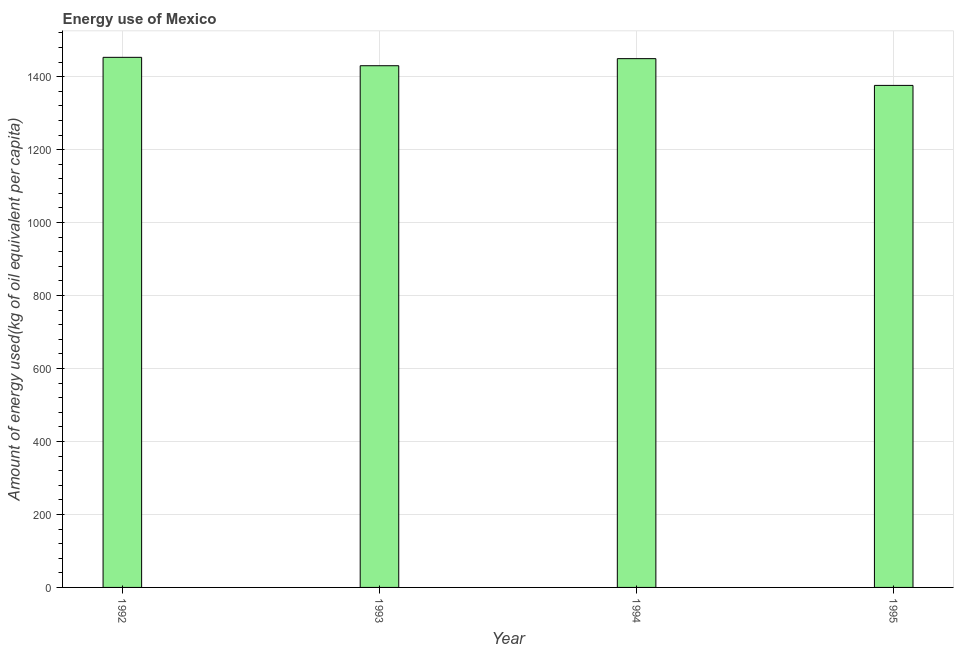What is the title of the graph?
Make the answer very short. Energy use of Mexico. What is the label or title of the X-axis?
Make the answer very short. Year. What is the label or title of the Y-axis?
Provide a short and direct response. Amount of energy used(kg of oil equivalent per capita). What is the amount of energy used in 1995?
Make the answer very short. 1376.02. Across all years, what is the maximum amount of energy used?
Provide a short and direct response. 1452.97. Across all years, what is the minimum amount of energy used?
Your response must be concise. 1376.02. In which year was the amount of energy used maximum?
Your answer should be compact. 1992. In which year was the amount of energy used minimum?
Your response must be concise. 1995. What is the sum of the amount of energy used?
Provide a succinct answer. 5708.33. What is the difference between the amount of energy used in 1993 and 1995?
Your answer should be very brief. 53.95. What is the average amount of energy used per year?
Your response must be concise. 1427.08. What is the median amount of energy used?
Offer a terse response. 1439.67. What is the ratio of the amount of energy used in 1992 to that in 1995?
Your response must be concise. 1.06. Is the difference between the amount of energy used in 1993 and 1994 greater than the difference between any two years?
Your response must be concise. No. What is the difference between the highest and the second highest amount of energy used?
Ensure brevity in your answer.  3.61. What is the difference between the highest and the lowest amount of energy used?
Offer a terse response. 76.95. In how many years, is the amount of energy used greater than the average amount of energy used taken over all years?
Provide a succinct answer. 3. How many bars are there?
Make the answer very short. 4. Are all the bars in the graph horizontal?
Your answer should be compact. No. How many years are there in the graph?
Offer a very short reply. 4. What is the difference between two consecutive major ticks on the Y-axis?
Provide a succinct answer. 200. What is the Amount of energy used(kg of oil equivalent per capita) of 1992?
Give a very brief answer. 1452.97. What is the Amount of energy used(kg of oil equivalent per capita) in 1993?
Ensure brevity in your answer.  1429.97. What is the Amount of energy used(kg of oil equivalent per capita) in 1994?
Keep it short and to the point. 1449.36. What is the Amount of energy used(kg of oil equivalent per capita) of 1995?
Your answer should be very brief. 1376.02. What is the difference between the Amount of energy used(kg of oil equivalent per capita) in 1992 and 1993?
Provide a succinct answer. 23. What is the difference between the Amount of energy used(kg of oil equivalent per capita) in 1992 and 1994?
Keep it short and to the point. 3.61. What is the difference between the Amount of energy used(kg of oil equivalent per capita) in 1992 and 1995?
Your answer should be compact. 76.95. What is the difference between the Amount of energy used(kg of oil equivalent per capita) in 1993 and 1994?
Give a very brief answer. -19.38. What is the difference between the Amount of energy used(kg of oil equivalent per capita) in 1993 and 1995?
Ensure brevity in your answer.  53.95. What is the difference between the Amount of energy used(kg of oil equivalent per capita) in 1994 and 1995?
Your response must be concise. 73.33. What is the ratio of the Amount of energy used(kg of oil equivalent per capita) in 1992 to that in 1995?
Make the answer very short. 1.06. What is the ratio of the Amount of energy used(kg of oil equivalent per capita) in 1993 to that in 1994?
Your response must be concise. 0.99. What is the ratio of the Amount of energy used(kg of oil equivalent per capita) in 1993 to that in 1995?
Your response must be concise. 1.04. What is the ratio of the Amount of energy used(kg of oil equivalent per capita) in 1994 to that in 1995?
Your answer should be compact. 1.05. 